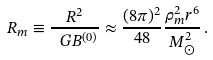<formula> <loc_0><loc_0><loc_500><loc_500>R _ { m } \equiv \frac { R ^ { 2 } } { \ G B ^ { ( 0 ) } } \approx \frac { ( 8 \pi ) ^ { 2 } } { 4 8 } \frac { \rho _ { m } ^ { 2 } r ^ { 6 } } { M _ { \odot } ^ { 2 } } \, .</formula> 